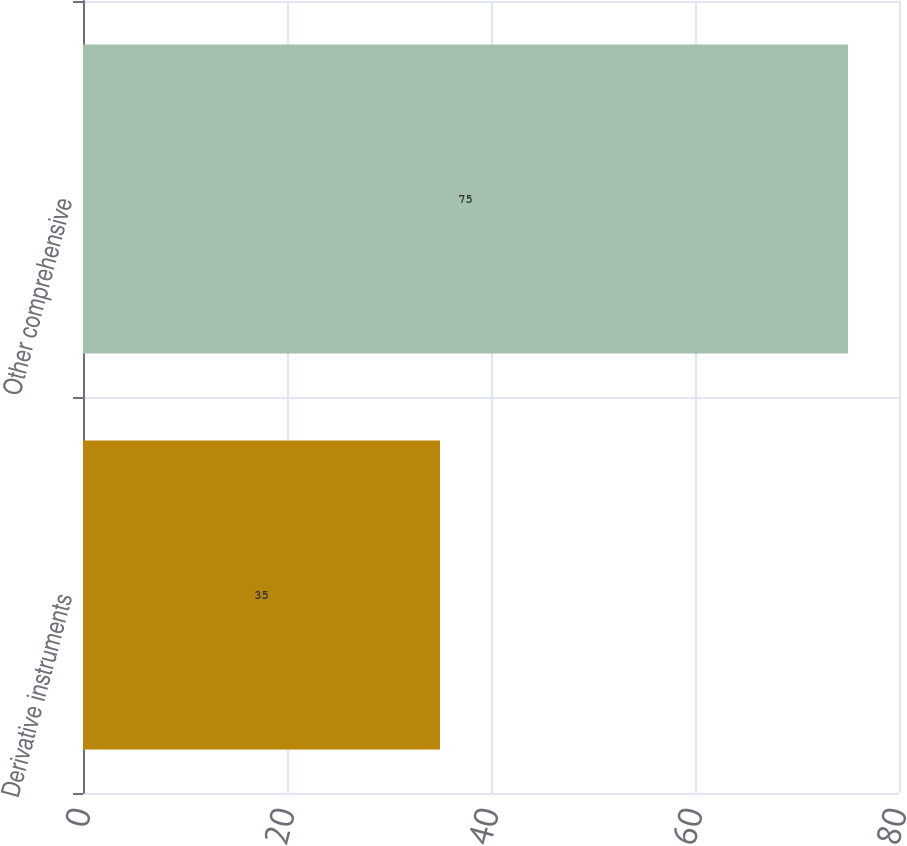Convert chart to OTSL. <chart><loc_0><loc_0><loc_500><loc_500><bar_chart><fcel>Derivative instruments<fcel>Other comprehensive<nl><fcel>35<fcel>75<nl></chart> 